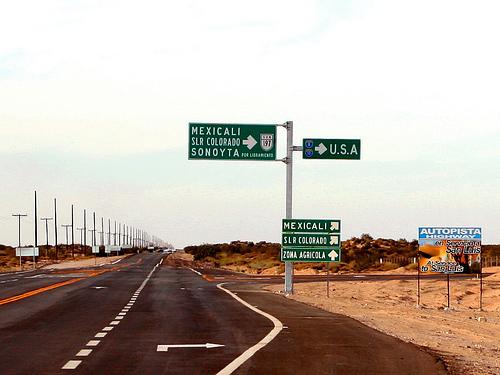How many cars are there?
Concise answer only. 0. Does this photo show train tracks?
Be succinct. No. Was this picture taken in the US?
Write a very short answer. No. Is anyone turning right at this intersection?
Give a very brief answer. No. 